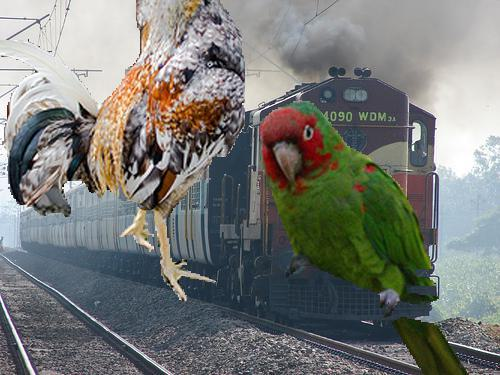What species of birds appear to be photobombing this train? The image depicts a parrot and a chicken as collage elements that appear to be unexpectedly entering the scene with the train. 